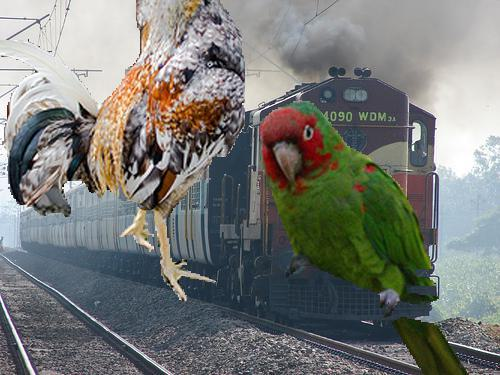What species of birds appear to be photobombing this train? The image depicts a parrot and a chicken as collage elements that appear to be unexpectedly entering the scene with the train. 